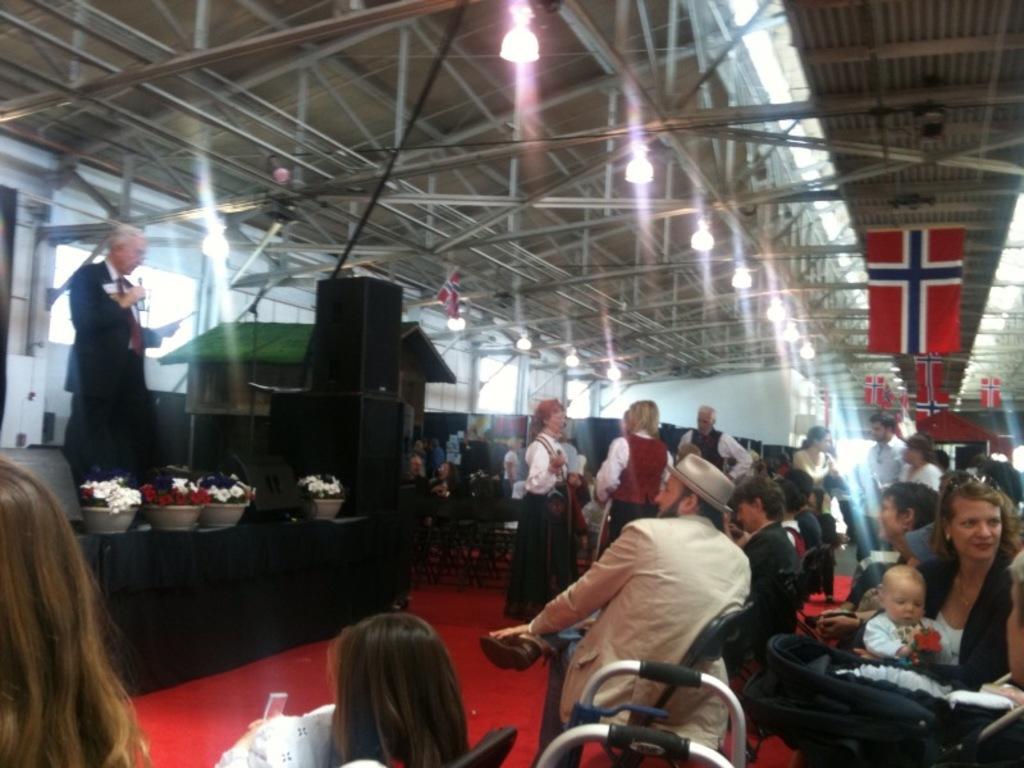Can you describe this image briefly? In the picture I can see a group of people. There is a man on the left side is wearing a suit and looks like he is speaking on a microphone. There are flower pots on the table on the left side. I can see a few people sitting on the chair and a few of them are standing on the carpet. I can see the flags on the roof on the right side. There is a lighting arrangement on the roof. 